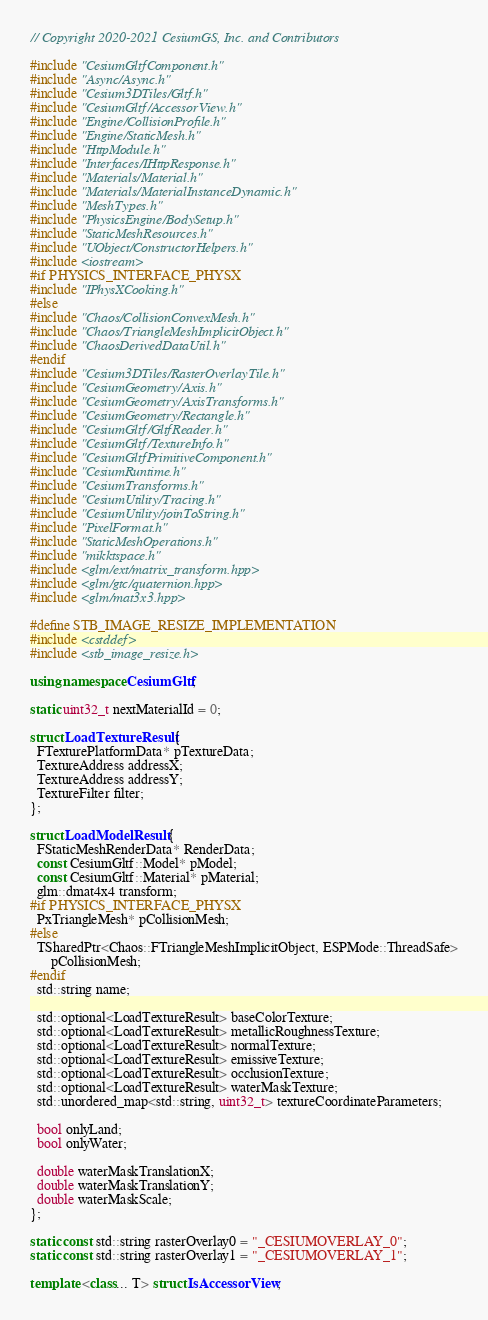<code> <loc_0><loc_0><loc_500><loc_500><_C++_>// Copyright 2020-2021 CesiumGS, Inc. and Contributors

#include "CesiumGltfComponent.h"
#include "Async/Async.h"
#include "Cesium3DTiles/Gltf.h"
#include "CesiumGltf/AccessorView.h"
#include "Engine/CollisionProfile.h"
#include "Engine/StaticMesh.h"
#include "HttpModule.h"
#include "Interfaces/IHttpResponse.h"
#include "Materials/Material.h"
#include "Materials/MaterialInstanceDynamic.h"
#include "MeshTypes.h"
#include "PhysicsEngine/BodySetup.h"
#include "StaticMeshResources.h"
#include "UObject/ConstructorHelpers.h"
#include <iostream>
#if PHYSICS_INTERFACE_PHYSX
#include "IPhysXCooking.h"
#else
#include "Chaos/CollisionConvexMesh.h"
#include "Chaos/TriangleMeshImplicitObject.h"
#include "ChaosDerivedDataUtil.h"
#endif
#include "Cesium3DTiles/RasterOverlayTile.h"
#include "CesiumGeometry/Axis.h"
#include "CesiumGeometry/AxisTransforms.h"
#include "CesiumGeometry/Rectangle.h"
#include "CesiumGltf/GltfReader.h"
#include "CesiumGltf/TextureInfo.h"
#include "CesiumGltfPrimitiveComponent.h"
#include "CesiumRuntime.h"
#include "CesiumTransforms.h"
#include "CesiumUtility/Tracing.h"
#include "CesiumUtility/joinToString.h"
#include "PixelFormat.h"
#include "StaticMeshOperations.h"
#include "mikktspace.h"
#include <glm/ext/matrix_transform.hpp>
#include <glm/gtc/quaternion.hpp>
#include <glm/mat3x3.hpp>

#define STB_IMAGE_RESIZE_IMPLEMENTATION
#include <cstddef>
#include <stb_image_resize.h>

using namespace CesiumGltf;

static uint32_t nextMaterialId = 0;

struct LoadTextureResult {
  FTexturePlatformData* pTextureData;
  TextureAddress addressX;
  TextureAddress addressY;
  TextureFilter filter;
};

struct LoadModelResult {
  FStaticMeshRenderData* RenderData;
  const CesiumGltf::Model* pModel;
  const CesiumGltf::Material* pMaterial;
  glm::dmat4x4 transform;
#if PHYSICS_INTERFACE_PHYSX
  PxTriangleMesh* pCollisionMesh;
#else
  TSharedPtr<Chaos::FTriangleMeshImplicitObject, ESPMode::ThreadSafe>
      pCollisionMesh;
#endif
  std::string name;

  std::optional<LoadTextureResult> baseColorTexture;
  std::optional<LoadTextureResult> metallicRoughnessTexture;
  std::optional<LoadTextureResult> normalTexture;
  std::optional<LoadTextureResult> emissiveTexture;
  std::optional<LoadTextureResult> occlusionTexture;
  std::optional<LoadTextureResult> waterMaskTexture;
  std::unordered_map<std::string, uint32_t> textureCoordinateParameters;

  bool onlyLand;
  bool onlyWater;

  double waterMaskTranslationX;
  double waterMaskTranslationY;
  double waterMaskScale;
};

static const std::string rasterOverlay0 = "_CESIUMOVERLAY_0";
static const std::string rasterOverlay1 = "_CESIUMOVERLAY_1";

template <class... T> struct IsAccessorView;
</code> 